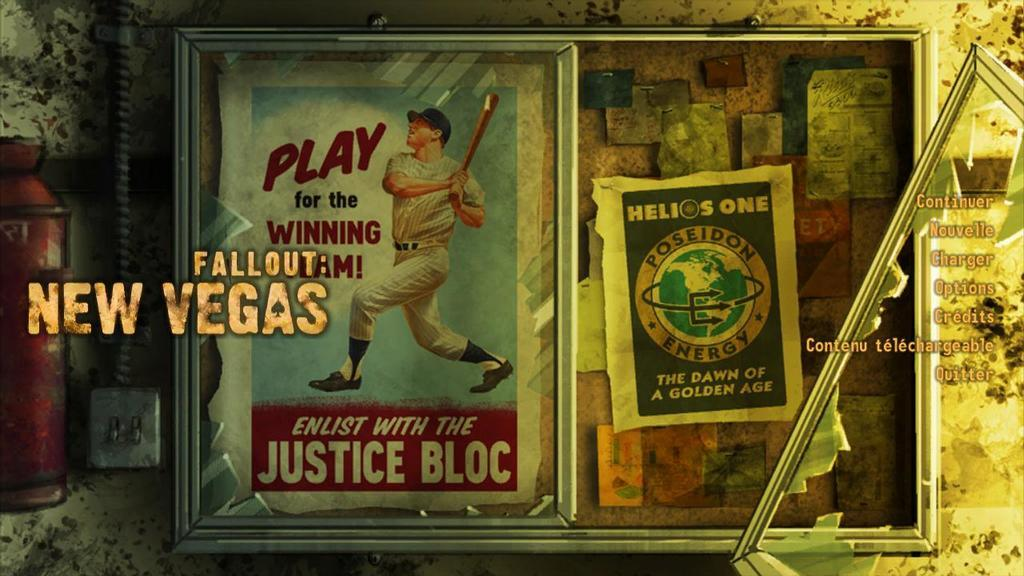<image>
Relay a brief, clear account of the picture shown. screen wth fallout: new vegas on it with broken glass display case with a baseball player swinging a bat in it 